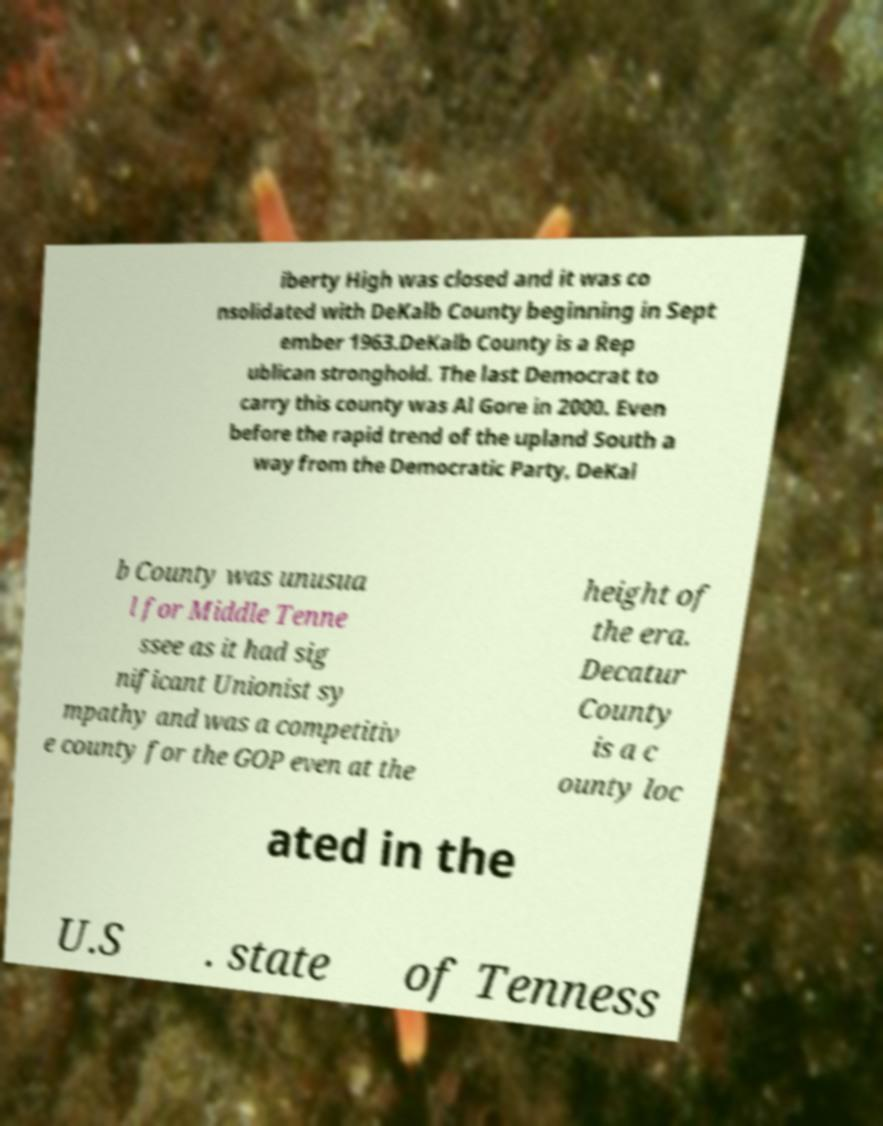What messages or text are displayed in this image? I need them in a readable, typed format. iberty High was closed and it was co nsolidated with DeKalb County beginning in Sept ember 1963.DeKalb County is a Rep ublican stronghold. The last Democrat to carry this county was Al Gore in 2000. Even before the rapid trend of the upland South a way from the Democratic Party, DeKal b County was unusua l for Middle Tenne ssee as it had sig nificant Unionist sy mpathy and was a competitiv e county for the GOP even at the height of the era. Decatur County is a c ounty loc ated in the U.S . state of Tenness 